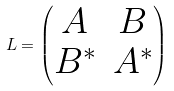<formula> <loc_0><loc_0><loc_500><loc_500>L = \begin{pmatrix} A & B \\ B ^ { * } & A ^ { * } \end{pmatrix}</formula> 